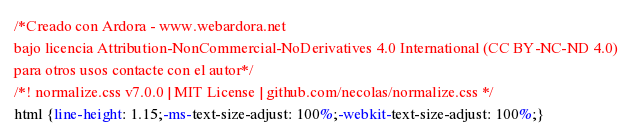Convert code to text. <code><loc_0><loc_0><loc_500><loc_500><_CSS_>/*Creado con Ardora - www.webardora.net
bajo licencia Attribution-NonCommercial-NoDerivatives 4.0 International (CC BY-NC-ND 4.0)
para otros usos contacte con el autor*/
/*! normalize.css v7.0.0 | MIT License | github.com/necolas/normalize.css */
html {line-height: 1.15;-ms-text-size-adjust: 100%;-webkit-text-size-adjust: 100%;}</code> 